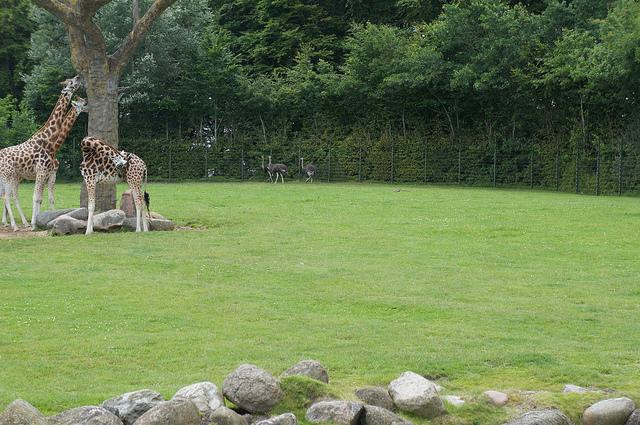The pattern on this animal most closely resembles the pattern on what other animal?

Choices:
A) robin
B) donkey
C) cheetah
D) zebra cheetah 